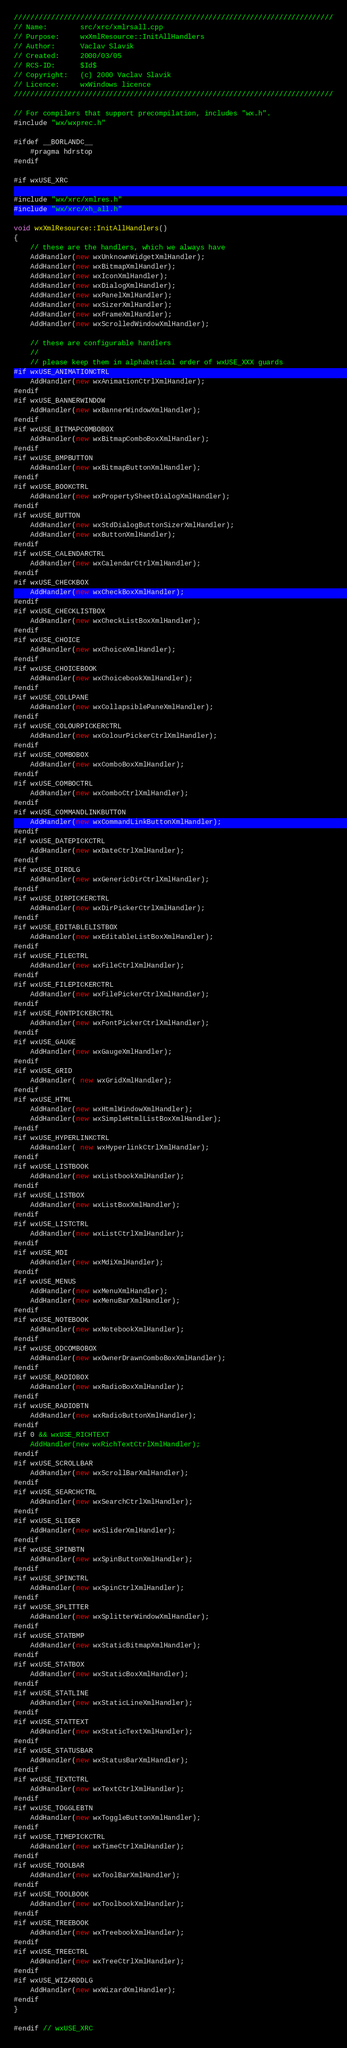Convert code to text. <code><loc_0><loc_0><loc_500><loc_500><_C++_>/////////////////////////////////////////////////////////////////////////////
// Name:        src/xrc/xmlrsall.cpp
// Purpose:     wxXmlResource::InitAllHandlers
// Author:      Vaclav Slavik
// Created:     2000/03/05
// RCS-ID:      $Id$
// Copyright:   (c) 2000 Vaclav Slavik
// Licence:     wxWindows licence
/////////////////////////////////////////////////////////////////////////////

// For compilers that support precompilation, includes "wx.h".
#include "wx/wxprec.h"

#ifdef __BORLANDC__
    #pragma hdrstop
#endif

#if wxUSE_XRC

#include "wx/xrc/xmlres.h"
#include "wx/xrc/xh_all.h"

void wxXmlResource::InitAllHandlers()
{
    // these are the handlers, which we always have
    AddHandler(new wxUnknownWidgetXmlHandler);
    AddHandler(new wxBitmapXmlHandler);
    AddHandler(new wxIconXmlHandler);
    AddHandler(new wxDialogXmlHandler);
    AddHandler(new wxPanelXmlHandler);
    AddHandler(new wxSizerXmlHandler);
    AddHandler(new wxFrameXmlHandler);
    AddHandler(new wxScrolledWindowXmlHandler);

    // these are configurable handlers
    //
    // please keep them in alphabetical order of wxUSE_XXX guards
#if wxUSE_ANIMATIONCTRL
    AddHandler(new wxAnimationCtrlXmlHandler);
#endif
#if wxUSE_BANNERWINDOW
    AddHandler(new wxBannerWindowXmlHandler);
#endif
#if wxUSE_BITMAPCOMBOBOX
    AddHandler(new wxBitmapComboBoxXmlHandler);
#endif
#if wxUSE_BMPBUTTON
    AddHandler(new wxBitmapButtonXmlHandler);
#endif
#if wxUSE_BOOKCTRL
    AddHandler(new wxPropertySheetDialogXmlHandler);
#endif
#if wxUSE_BUTTON
    AddHandler(new wxStdDialogButtonSizerXmlHandler);
    AddHandler(new wxButtonXmlHandler);
#endif
#if wxUSE_CALENDARCTRL
    AddHandler(new wxCalendarCtrlXmlHandler);
#endif
#if wxUSE_CHECKBOX
    AddHandler(new wxCheckBoxXmlHandler);
#endif
#if wxUSE_CHECKLISTBOX
    AddHandler(new wxCheckListBoxXmlHandler);
#endif
#if wxUSE_CHOICE
    AddHandler(new wxChoiceXmlHandler);
#endif
#if wxUSE_CHOICEBOOK
    AddHandler(new wxChoicebookXmlHandler);
#endif
#if wxUSE_COLLPANE
    AddHandler(new wxCollapsiblePaneXmlHandler);
#endif
#if wxUSE_COLOURPICKERCTRL
    AddHandler(new wxColourPickerCtrlXmlHandler);
#endif
#if wxUSE_COMBOBOX
    AddHandler(new wxComboBoxXmlHandler);
#endif
#if wxUSE_COMBOCTRL
    AddHandler(new wxComboCtrlXmlHandler);
#endif
#if wxUSE_COMMANDLINKBUTTON
    AddHandler(new wxCommandLinkButtonXmlHandler);
#endif
#if wxUSE_DATEPICKCTRL
    AddHandler(new wxDateCtrlXmlHandler);
#endif
#if wxUSE_DIRDLG
    AddHandler(new wxGenericDirCtrlXmlHandler);
#endif
#if wxUSE_DIRPICKERCTRL
    AddHandler(new wxDirPickerCtrlXmlHandler);
#endif
#if wxUSE_EDITABLELISTBOX
    AddHandler(new wxEditableListBoxXmlHandler);
#endif
#if wxUSE_FILECTRL
    AddHandler(new wxFileCtrlXmlHandler);
#endif
#if wxUSE_FILEPICKERCTRL
    AddHandler(new wxFilePickerCtrlXmlHandler);
#endif
#if wxUSE_FONTPICKERCTRL
    AddHandler(new wxFontPickerCtrlXmlHandler);
#endif
#if wxUSE_GAUGE
    AddHandler(new wxGaugeXmlHandler);
#endif
#if wxUSE_GRID
    AddHandler( new wxGridXmlHandler);
#endif
#if wxUSE_HTML
    AddHandler(new wxHtmlWindowXmlHandler);
    AddHandler(new wxSimpleHtmlListBoxXmlHandler);
#endif
#if wxUSE_HYPERLINKCTRL
    AddHandler( new wxHyperlinkCtrlXmlHandler);
#endif
#if wxUSE_LISTBOOK
    AddHandler(new wxListbookXmlHandler);
#endif
#if wxUSE_LISTBOX
    AddHandler(new wxListBoxXmlHandler);
#endif
#if wxUSE_LISTCTRL
    AddHandler(new wxListCtrlXmlHandler);
#endif
#if wxUSE_MDI
    AddHandler(new wxMdiXmlHandler);
#endif
#if wxUSE_MENUS
    AddHandler(new wxMenuXmlHandler);
    AddHandler(new wxMenuBarXmlHandler);
#endif
#if wxUSE_NOTEBOOK
    AddHandler(new wxNotebookXmlHandler);
#endif
#if wxUSE_ODCOMBOBOX
    AddHandler(new wxOwnerDrawnComboBoxXmlHandler);
#endif
#if wxUSE_RADIOBOX
    AddHandler(new wxRadioBoxXmlHandler);
#endif
#if wxUSE_RADIOBTN
    AddHandler(new wxRadioButtonXmlHandler);
#endif
#if 0 && wxUSE_RICHTEXT
    AddHandler(new wxRichTextCtrlXmlHandler);
#endif
#if wxUSE_SCROLLBAR
    AddHandler(new wxScrollBarXmlHandler);
#endif
#if wxUSE_SEARCHCTRL
    AddHandler(new wxSearchCtrlXmlHandler);
#endif
#if wxUSE_SLIDER
    AddHandler(new wxSliderXmlHandler);
#endif
#if wxUSE_SPINBTN
    AddHandler(new wxSpinButtonXmlHandler);
#endif
#if wxUSE_SPINCTRL
    AddHandler(new wxSpinCtrlXmlHandler);
#endif
#if wxUSE_SPLITTER
    AddHandler(new wxSplitterWindowXmlHandler);
#endif
#if wxUSE_STATBMP
    AddHandler(new wxStaticBitmapXmlHandler);
#endif
#if wxUSE_STATBOX
    AddHandler(new wxStaticBoxXmlHandler);
#endif
#if wxUSE_STATLINE
    AddHandler(new wxStaticLineXmlHandler);
#endif
#if wxUSE_STATTEXT
    AddHandler(new wxStaticTextXmlHandler);
#endif
#if wxUSE_STATUSBAR
    AddHandler(new wxStatusBarXmlHandler);
#endif
#if wxUSE_TEXTCTRL
    AddHandler(new wxTextCtrlXmlHandler);
#endif
#if wxUSE_TOGGLEBTN
    AddHandler(new wxToggleButtonXmlHandler);
#endif
#if wxUSE_TIMEPICKCTRL
    AddHandler(new wxTimeCtrlXmlHandler);
#endif
#if wxUSE_TOOLBAR
    AddHandler(new wxToolBarXmlHandler);
#endif
#if wxUSE_TOOLBOOK
    AddHandler(new wxToolbookXmlHandler);
#endif
#if wxUSE_TREEBOOK
    AddHandler(new wxTreebookXmlHandler);
#endif
#if wxUSE_TREECTRL
    AddHandler(new wxTreeCtrlXmlHandler);
#endif
#if wxUSE_WIZARDDLG
    AddHandler(new wxWizardXmlHandler);
#endif
}

#endif // wxUSE_XRC
</code> 